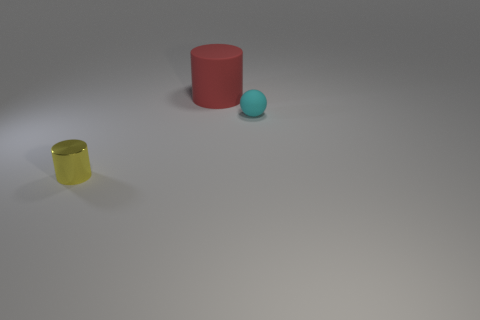Add 2 large yellow balls. How many objects exist? 5 Subtract all spheres. How many objects are left? 2 Subtract all spheres. Subtract all small matte things. How many objects are left? 1 Add 3 tiny yellow shiny cylinders. How many tiny yellow shiny cylinders are left? 4 Add 1 yellow cylinders. How many yellow cylinders exist? 2 Subtract 0 gray blocks. How many objects are left? 3 